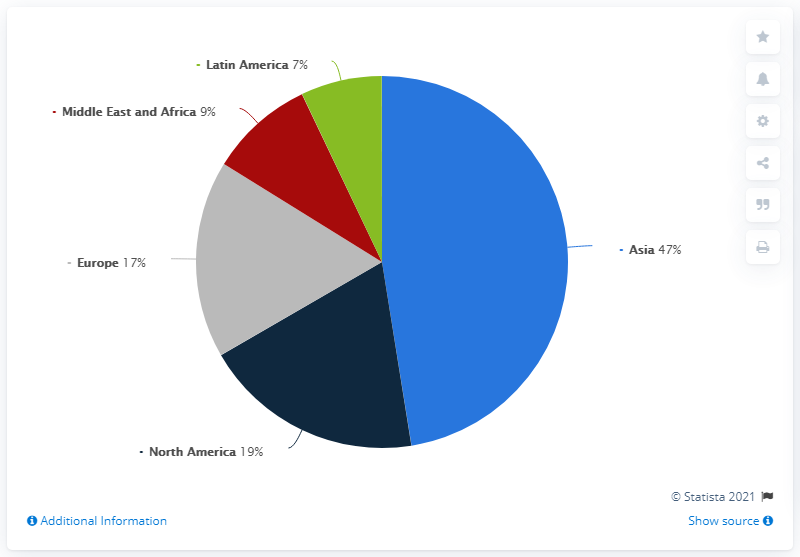Give some essential details in this illustration. Latin America is significantly smaller than Asia in terms of its population. Europe is the country that comes in the middle when arranged from highest to lowest. In 2019, it is projected that Europe will hold approximately 17% of the global smartphone market. In 2019, North America and Europe are expected to account for only 19% of the global smartphone market. 